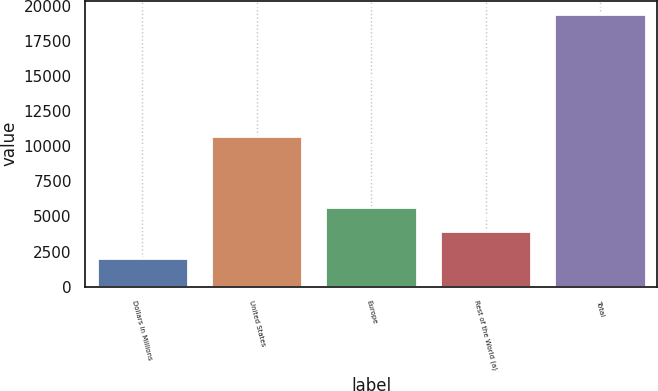Convert chart to OTSL. <chart><loc_0><loc_0><loc_500><loc_500><bar_chart><fcel>Dollars in Millions<fcel>United States<fcel>Europe<fcel>Rest of the World (a)<fcel>Total<nl><fcel>2016<fcel>10720<fcel>5705.1<fcel>3964<fcel>19427<nl></chart> 